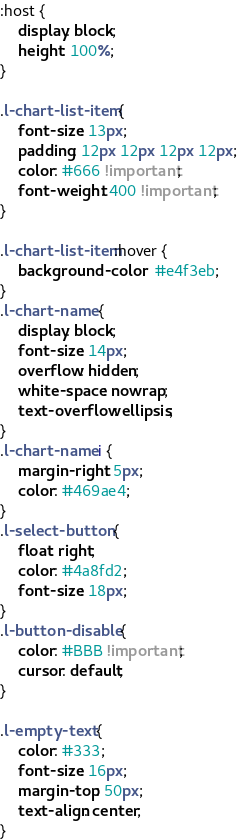Convert code to text. <code><loc_0><loc_0><loc_500><loc_500><_CSS_>:host {
    display: block;
    height: 100%;
}

.l-chart-list-item {
    font-size: 13px;
    padding: 12px 12px 12px 12px;
    color: #666 !important;
    font-weight: 400 !important;
}

.l-chart-list-item:hover {
    background-color:  #e4f3eb;
}
.l-chart-name {
    display: block;
    font-size: 14px;
    overflow: hidden;
    white-space: nowrap;
    text-overflow: ellipsis;
}
.l-chart-name i {
    margin-right: 5px;
    color: #469ae4;
}
.l-select-button {
    float: right;
    color: #4a8fd2;
    font-size: 18px;
}
.l-button-disable {
    color: #BBB !important;
    cursor: default;
}

.l-empty-text {
    color: #333;
    font-size: 16px;
    margin-top: 50px;
    text-align: center;
}
</code> 